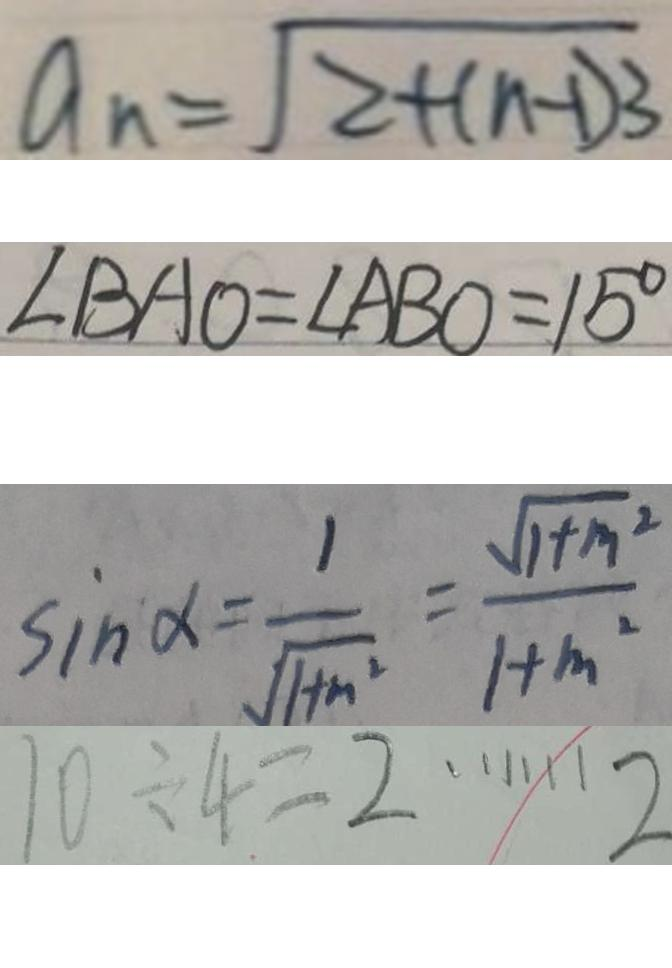Convert formula to latex. <formula><loc_0><loc_0><loc_500><loc_500>a _ { n } = \sqrt { 2 + ( n - 1 ) 3 } 
 \angle B A O = \angle A B O = 1 5 ^ { \circ } 
 \sin \alpha = \frac { 1 } { \sqrt { 1 + n ^ { 2 } } } = \frac { \sqrt { 1 + m ^ { 2 } } } { 1 + m ^ { 2 } } 
 1 0 \div 4 = 2 \cdots 2</formula> 